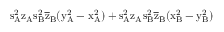Convert formula to latex. <formula><loc_0><loc_0><loc_500><loc_500>s _ { A } ^ { 2 } \mathrm { z _ { A } \mathrm { s _ { B } ^ { 2 } \mathrm { \overline { z } _ { B } ( \mathrm { y _ { A } ^ { 2 } - \mathrm { x _ { A } ^ { 2 } ) + \mathrm { s _ { A } ^ { 2 } \mathrm { z _ { A } \mathrm { s _ { B } ^ { 2 } \mathrm { \overline { z } _ { B } ( \mathrm { x _ { B } ^ { 2 } - \mathrm { y _ { B } ^ { 2 } ) } } } } } } } } } } }</formula> 